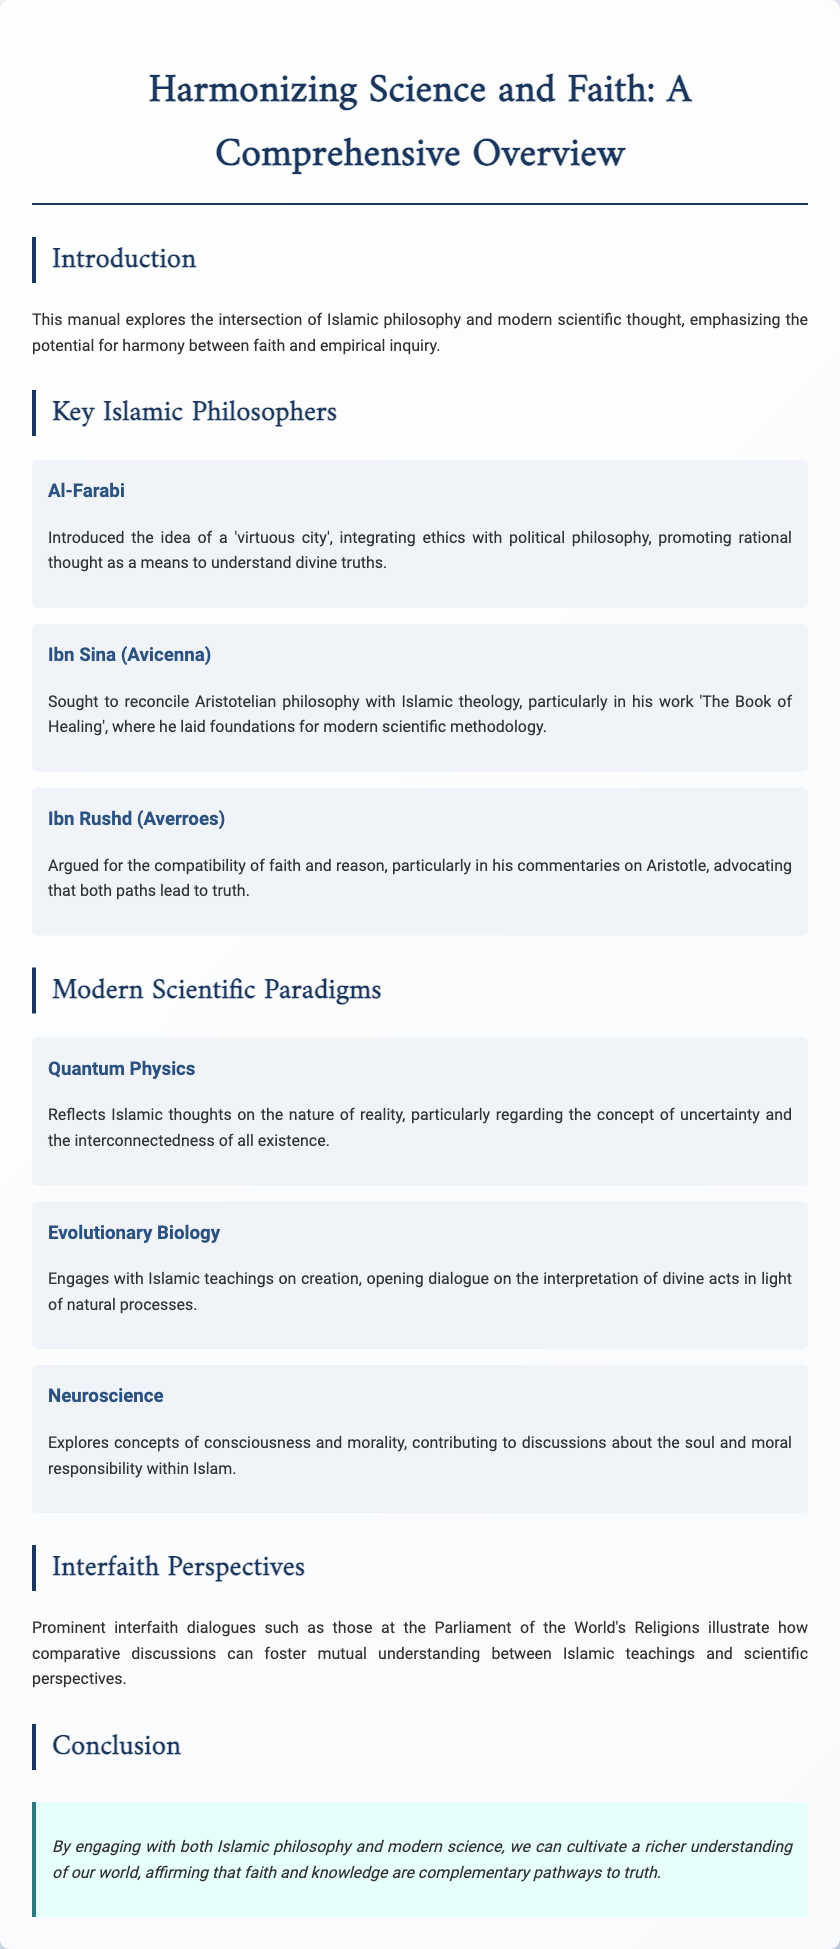What is the title of the document? The title is provided at the top of the document and reflects the main theme, which is essential for understanding the content.
Answer: Harmonizing Science and Faith: A Comprehensive Overview Who is one of the key Islamic philosophers mentioned? The document introduces three significant philosophers, representing important contributions to the integration of faith and philosophy.
Answer: Al-Farabi What is the main topic of the section on quantum physics? The section discusses how quantum physics connects with Islamic thoughts, particularly focusing on specific concepts outlined in the document.
Answer: Uncertainty and interconnectedness In which section is the interfaith dialogue discussed? The interfaith perspectives are presented in a designated section that emphasizes comparative discussions to foster understanding.
Answer: Interfaith Perspectives How many prominent philosophers are highlighted in the document? The document lists multiple philosophers across various sections, highlighting their contributions to Islamic thought.
Answer: Three What concept does neuroscience explore concerning Islamic teachings? The section discusses the intersection of neuroscience with the concepts addressed in Islamic philosophy, specifically relating to moral aspects.
Answer: Consciousness and morality What conclusion is drawn about the relationship between faith and knowledge? The conclusion synthesizes the ideas presented throughout the manual, emphasizing a key insight about the nature of faith in relation to knowledge.
Answer: Complementary pathways to truth 